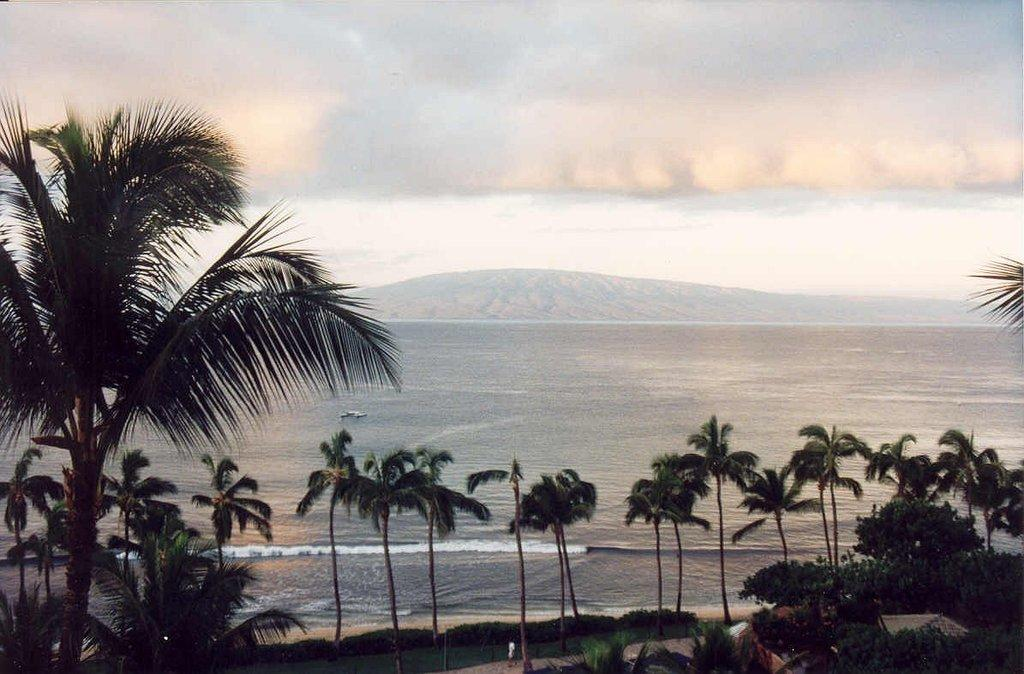What type of trees can be seen in the image? There are palm trees in the image. What is located in the middle of the ocean in the image? There is a boat in the middle of the ocean in the image. What can be seen in the background of the image? There is a hill visible in the background. What is visible in the sky in the image? The sky is visible in the image, and clouds are present. What relation does the caption have to the image? There is no caption present in the image, so it is not possible to determine any relation. What unit of measurement is used to describe the size of the clouds in the image? The provided facts do not mention any specific unit of measurement for the clouds, so it is not possible to determine the unit used. 